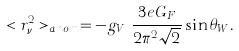<formula> <loc_0><loc_0><loc_500><loc_500>< r ^ { 2 } _ { \nu _ { l } } > _ { a n o m } = - g _ { V _ { \nu _ { l } } } \frac { 3 e G _ { F } } { 2 \pi ^ { 2 } \sqrt { 2 } } \sin \theta _ { W } .</formula> 